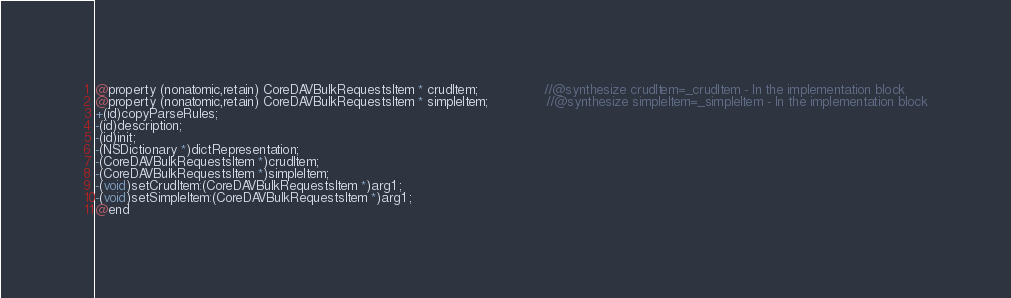Convert code to text. <code><loc_0><loc_0><loc_500><loc_500><_C_>@property (nonatomic,retain) CoreDAVBulkRequestsItem * crudItem;                //@synthesize crudItem=_crudItem - In the implementation block
@property (nonatomic,retain) CoreDAVBulkRequestsItem * simpleItem;              //@synthesize simpleItem=_simpleItem - In the implementation block
+(id)copyParseRules;
-(id)description;
-(id)init;
-(NSDictionary *)dictRepresentation;
-(CoreDAVBulkRequestsItem *)crudItem;
-(CoreDAVBulkRequestsItem *)simpleItem;
-(void)setCrudItem:(CoreDAVBulkRequestsItem *)arg1 ;
-(void)setSimpleItem:(CoreDAVBulkRequestsItem *)arg1 ;
@end

</code> 